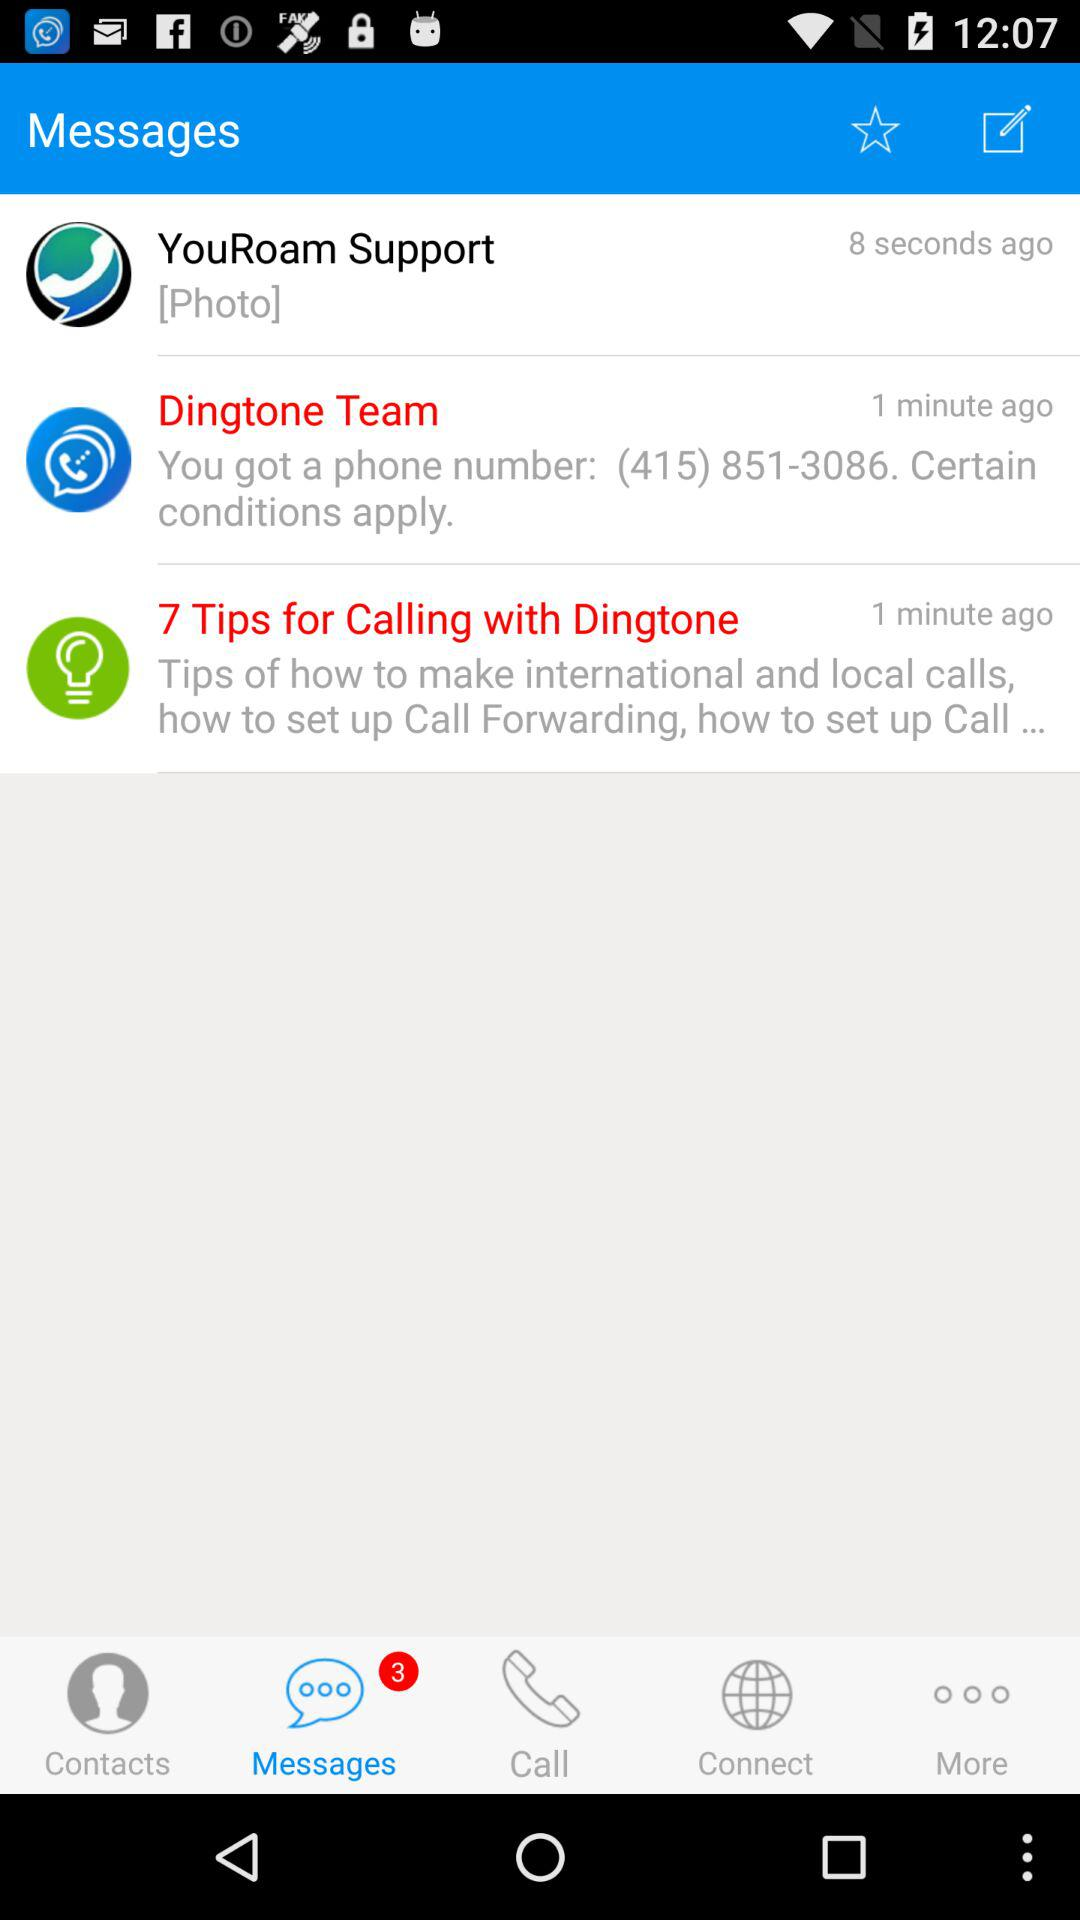Who is listed as a contact?
When the provided information is insufficient, respond with <no answer>. <no answer> 